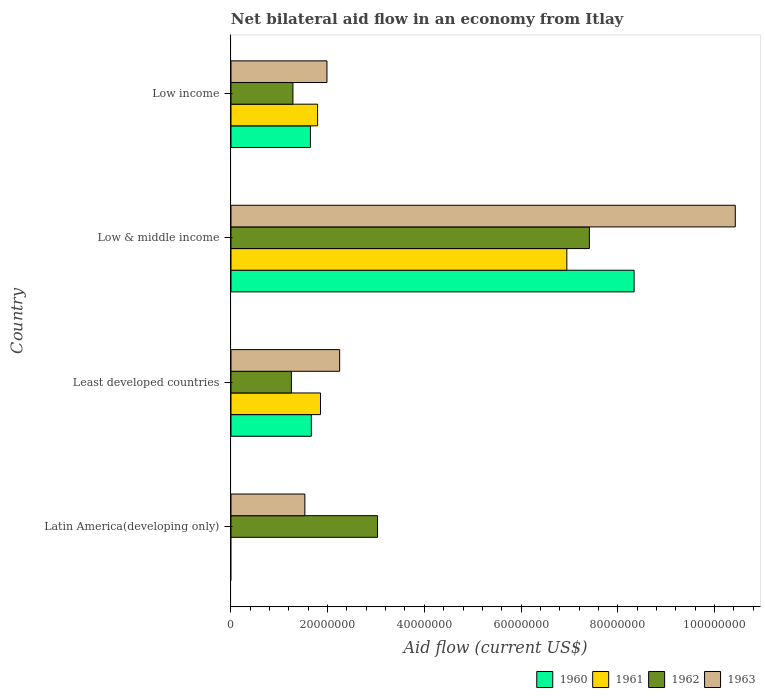How many different coloured bars are there?
Make the answer very short. 4. How many bars are there on the 4th tick from the top?
Your answer should be very brief. 2. What is the label of the 3rd group of bars from the top?
Keep it short and to the point. Least developed countries. In how many cases, is the number of bars for a given country not equal to the number of legend labels?
Offer a very short reply. 1. What is the net bilateral aid flow in 1962 in Low income?
Your answer should be compact. 1.28e+07. Across all countries, what is the maximum net bilateral aid flow in 1960?
Provide a short and direct response. 8.34e+07. Across all countries, what is the minimum net bilateral aid flow in 1963?
Your answer should be compact. 1.53e+07. What is the total net bilateral aid flow in 1963 in the graph?
Provide a succinct answer. 1.62e+08. What is the difference between the net bilateral aid flow in 1963 in Latin America(developing only) and that in Low income?
Make the answer very short. -4.58e+06. What is the difference between the net bilateral aid flow in 1963 in Least developed countries and the net bilateral aid flow in 1961 in Low & middle income?
Ensure brevity in your answer.  -4.70e+07. What is the average net bilateral aid flow in 1962 per country?
Keep it short and to the point. 3.24e+07. What is the difference between the net bilateral aid flow in 1961 and net bilateral aid flow in 1962 in Low & middle income?
Keep it short and to the point. -4.67e+06. What is the ratio of the net bilateral aid flow in 1961 in Least developed countries to that in Low income?
Offer a terse response. 1.03. What is the difference between the highest and the second highest net bilateral aid flow in 1961?
Make the answer very short. 5.10e+07. What is the difference between the highest and the lowest net bilateral aid flow in 1961?
Offer a terse response. 6.95e+07. Is it the case that in every country, the sum of the net bilateral aid flow in 1963 and net bilateral aid flow in 1960 is greater than the sum of net bilateral aid flow in 1962 and net bilateral aid flow in 1961?
Keep it short and to the point. No. Is it the case that in every country, the sum of the net bilateral aid flow in 1963 and net bilateral aid flow in 1962 is greater than the net bilateral aid flow in 1960?
Make the answer very short. Yes. Are all the bars in the graph horizontal?
Provide a short and direct response. Yes. How many countries are there in the graph?
Ensure brevity in your answer.  4. Does the graph contain any zero values?
Your answer should be very brief. Yes. Where does the legend appear in the graph?
Give a very brief answer. Bottom right. How many legend labels are there?
Your answer should be very brief. 4. What is the title of the graph?
Offer a terse response. Net bilateral aid flow in an economy from Itlay. What is the label or title of the X-axis?
Give a very brief answer. Aid flow (current US$). What is the label or title of the Y-axis?
Ensure brevity in your answer.  Country. What is the Aid flow (current US$) in 1960 in Latin America(developing only)?
Your response must be concise. 0. What is the Aid flow (current US$) in 1962 in Latin America(developing only)?
Ensure brevity in your answer.  3.03e+07. What is the Aid flow (current US$) in 1963 in Latin America(developing only)?
Ensure brevity in your answer.  1.53e+07. What is the Aid flow (current US$) in 1960 in Least developed countries?
Make the answer very short. 1.66e+07. What is the Aid flow (current US$) in 1961 in Least developed countries?
Offer a terse response. 1.85e+07. What is the Aid flow (current US$) in 1962 in Least developed countries?
Offer a very short reply. 1.25e+07. What is the Aid flow (current US$) of 1963 in Least developed countries?
Make the answer very short. 2.25e+07. What is the Aid flow (current US$) in 1960 in Low & middle income?
Offer a very short reply. 8.34e+07. What is the Aid flow (current US$) in 1961 in Low & middle income?
Provide a short and direct response. 6.95e+07. What is the Aid flow (current US$) of 1962 in Low & middle income?
Keep it short and to the point. 7.42e+07. What is the Aid flow (current US$) of 1963 in Low & middle income?
Give a very brief answer. 1.04e+08. What is the Aid flow (current US$) in 1960 in Low income?
Your response must be concise. 1.64e+07. What is the Aid flow (current US$) in 1961 in Low income?
Ensure brevity in your answer.  1.79e+07. What is the Aid flow (current US$) of 1962 in Low income?
Offer a very short reply. 1.28e+07. What is the Aid flow (current US$) of 1963 in Low income?
Offer a very short reply. 1.99e+07. Across all countries, what is the maximum Aid flow (current US$) of 1960?
Give a very brief answer. 8.34e+07. Across all countries, what is the maximum Aid flow (current US$) in 1961?
Your response must be concise. 6.95e+07. Across all countries, what is the maximum Aid flow (current US$) in 1962?
Make the answer very short. 7.42e+07. Across all countries, what is the maximum Aid flow (current US$) of 1963?
Keep it short and to the point. 1.04e+08. Across all countries, what is the minimum Aid flow (current US$) in 1960?
Offer a very short reply. 0. Across all countries, what is the minimum Aid flow (current US$) in 1962?
Your answer should be very brief. 1.25e+07. Across all countries, what is the minimum Aid flow (current US$) of 1963?
Keep it short and to the point. 1.53e+07. What is the total Aid flow (current US$) of 1960 in the graph?
Offer a very short reply. 1.16e+08. What is the total Aid flow (current US$) in 1961 in the graph?
Make the answer very short. 1.06e+08. What is the total Aid flow (current US$) in 1962 in the graph?
Make the answer very short. 1.30e+08. What is the total Aid flow (current US$) in 1963 in the graph?
Provide a short and direct response. 1.62e+08. What is the difference between the Aid flow (current US$) in 1962 in Latin America(developing only) and that in Least developed countries?
Your answer should be compact. 1.78e+07. What is the difference between the Aid flow (current US$) in 1963 in Latin America(developing only) and that in Least developed countries?
Offer a terse response. -7.20e+06. What is the difference between the Aid flow (current US$) in 1962 in Latin America(developing only) and that in Low & middle income?
Provide a succinct answer. -4.38e+07. What is the difference between the Aid flow (current US$) in 1963 in Latin America(developing only) and that in Low & middle income?
Provide a short and direct response. -8.90e+07. What is the difference between the Aid flow (current US$) in 1962 in Latin America(developing only) and that in Low income?
Offer a very short reply. 1.75e+07. What is the difference between the Aid flow (current US$) in 1963 in Latin America(developing only) and that in Low income?
Ensure brevity in your answer.  -4.58e+06. What is the difference between the Aid flow (current US$) of 1960 in Least developed countries and that in Low & middle income?
Give a very brief answer. -6.68e+07. What is the difference between the Aid flow (current US$) of 1961 in Least developed countries and that in Low & middle income?
Offer a very short reply. -5.10e+07. What is the difference between the Aid flow (current US$) of 1962 in Least developed countries and that in Low & middle income?
Your response must be concise. -6.16e+07. What is the difference between the Aid flow (current US$) of 1963 in Least developed countries and that in Low & middle income?
Your answer should be compact. -8.18e+07. What is the difference between the Aid flow (current US$) in 1960 in Least developed countries and that in Low income?
Your answer should be very brief. 1.90e+05. What is the difference between the Aid flow (current US$) of 1962 in Least developed countries and that in Low income?
Make the answer very short. -3.20e+05. What is the difference between the Aid flow (current US$) in 1963 in Least developed countries and that in Low income?
Make the answer very short. 2.62e+06. What is the difference between the Aid flow (current US$) in 1960 in Low & middle income and that in Low income?
Provide a succinct answer. 6.70e+07. What is the difference between the Aid flow (current US$) of 1961 in Low & middle income and that in Low income?
Make the answer very short. 5.16e+07. What is the difference between the Aid flow (current US$) in 1962 in Low & middle income and that in Low income?
Your response must be concise. 6.13e+07. What is the difference between the Aid flow (current US$) in 1963 in Low & middle income and that in Low income?
Offer a very short reply. 8.45e+07. What is the difference between the Aid flow (current US$) of 1962 in Latin America(developing only) and the Aid flow (current US$) of 1963 in Least developed countries?
Offer a very short reply. 7.84e+06. What is the difference between the Aid flow (current US$) of 1962 in Latin America(developing only) and the Aid flow (current US$) of 1963 in Low & middle income?
Your answer should be very brief. -7.40e+07. What is the difference between the Aid flow (current US$) of 1962 in Latin America(developing only) and the Aid flow (current US$) of 1963 in Low income?
Give a very brief answer. 1.05e+07. What is the difference between the Aid flow (current US$) of 1960 in Least developed countries and the Aid flow (current US$) of 1961 in Low & middle income?
Your response must be concise. -5.28e+07. What is the difference between the Aid flow (current US$) of 1960 in Least developed countries and the Aid flow (current US$) of 1962 in Low & middle income?
Your answer should be compact. -5.75e+07. What is the difference between the Aid flow (current US$) in 1960 in Least developed countries and the Aid flow (current US$) in 1963 in Low & middle income?
Make the answer very short. -8.77e+07. What is the difference between the Aid flow (current US$) in 1961 in Least developed countries and the Aid flow (current US$) in 1962 in Low & middle income?
Your answer should be very brief. -5.56e+07. What is the difference between the Aid flow (current US$) in 1961 in Least developed countries and the Aid flow (current US$) in 1963 in Low & middle income?
Offer a very short reply. -8.58e+07. What is the difference between the Aid flow (current US$) of 1962 in Least developed countries and the Aid flow (current US$) of 1963 in Low & middle income?
Your response must be concise. -9.18e+07. What is the difference between the Aid flow (current US$) of 1960 in Least developed countries and the Aid flow (current US$) of 1961 in Low income?
Offer a very short reply. -1.29e+06. What is the difference between the Aid flow (current US$) in 1960 in Least developed countries and the Aid flow (current US$) in 1962 in Low income?
Offer a terse response. 3.81e+06. What is the difference between the Aid flow (current US$) in 1960 in Least developed countries and the Aid flow (current US$) in 1963 in Low income?
Give a very brief answer. -3.23e+06. What is the difference between the Aid flow (current US$) in 1961 in Least developed countries and the Aid flow (current US$) in 1962 in Low income?
Keep it short and to the point. 5.70e+06. What is the difference between the Aid flow (current US$) of 1961 in Least developed countries and the Aid flow (current US$) of 1963 in Low income?
Make the answer very short. -1.34e+06. What is the difference between the Aid flow (current US$) of 1962 in Least developed countries and the Aid flow (current US$) of 1963 in Low income?
Make the answer very short. -7.36e+06. What is the difference between the Aid flow (current US$) in 1960 in Low & middle income and the Aid flow (current US$) in 1961 in Low income?
Your response must be concise. 6.55e+07. What is the difference between the Aid flow (current US$) in 1960 in Low & middle income and the Aid flow (current US$) in 1962 in Low income?
Keep it short and to the point. 7.06e+07. What is the difference between the Aid flow (current US$) in 1960 in Low & middle income and the Aid flow (current US$) in 1963 in Low income?
Make the answer very short. 6.35e+07. What is the difference between the Aid flow (current US$) of 1961 in Low & middle income and the Aid flow (current US$) of 1962 in Low income?
Provide a short and direct response. 5.67e+07. What is the difference between the Aid flow (current US$) in 1961 in Low & middle income and the Aid flow (current US$) in 1963 in Low income?
Provide a short and direct response. 4.96e+07. What is the difference between the Aid flow (current US$) of 1962 in Low & middle income and the Aid flow (current US$) of 1963 in Low income?
Provide a succinct answer. 5.43e+07. What is the average Aid flow (current US$) of 1960 per country?
Offer a very short reply. 2.91e+07. What is the average Aid flow (current US$) in 1961 per country?
Provide a succinct answer. 2.65e+07. What is the average Aid flow (current US$) in 1962 per country?
Make the answer very short. 3.24e+07. What is the average Aid flow (current US$) in 1963 per country?
Your response must be concise. 4.05e+07. What is the difference between the Aid flow (current US$) in 1962 and Aid flow (current US$) in 1963 in Latin America(developing only)?
Your answer should be compact. 1.50e+07. What is the difference between the Aid flow (current US$) in 1960 and Aid flow (current US$) in 1961 in Least developed countries?
Your answer should be very brief. -1.89e+06. What is the difference between the Aid flow (current US$) in 1960 and Aid flow (current US$) in 1962 in Least developed countries?
Give a very brief answer. 4.13e+06. What is the difference between the Aid flow (current US$) in 1960 and Aid flow (current US$) in 1963 in Least developed countries?
Make the answer very short. -5.85e+06. What is the difference between the Aid flow (current US$) in 1961 and Aid flow (current US$) in 1962 in Least developed countries?
Your response must be concise. 6.02e+06. What is the difference between the Aid flow (current US$) in 1961 and Aid flow (current US$) in 1963 in Least developed countries?
Your answer should be very brief. -3.96e+06. What is the difference between the Aid flow (current US$) in 1962 and Aid flow (current US$) in 1963 in Least developed countries?
Your answer should be compact. -9.98e+06. What is the difference between the Aid flow (current US$) in 1960 and Aid flow (current US$) in 1961 in Low & middle income?
Your response must be concise. 1.39e+07. What is the difference between the Aid flow (current US$) of 1960 and Aid flow (current US$) of 1962 in Low & middle income?
Offer a terse response. 9.25e+06. What is the difference between the Aid flow (current US$) in 1960 and Aid flow (current US$) in 1963 in Low & middle income?
Give a very brief answer. -2.09e+07. What is the difference between the Aid flow (current US$) in 1961 and Aid flow (current US$) in 1962 in Low & middle income?
Your response must be concise. -4.67e+06. What is the difference between the Aid flow (current US$) of 1961 and Aid flow (current US$) of 1963 in Low & middle income?
Offer a terse response. -3.48e+07. What is the difference between the Aid flow (current US$) of 1962 and Aid flow (current US$) of 1963 in Low & middle income?
Offer a terse response. -3.02e+07. What is the difference between the Aid flow (current US$) in 1960 and Aid flow (current US$) in 1961 in Low income?
Offer a terse response. -1.48e+06. What is the difference between the Aid flow (current US$) in 1960 and Aid flow (current US$) in 1962 in Low income?
Your response must be concise. 3.62e+06. What is the difference between the Aid flow (current US$) of 1960 and Aid flow (current US$) of 1963 in Low income?
Your answer should be compact. -3.42e+06. What is the difference between the Aid flow (current US$) of 1961 and Aid flow (current US$) of 1962 in Low income?
Your response must be concise. 5.10e+06. What is the difference between the Aid flow (current US$) of 1961 and Aid flow (current US$) of 1963 in Low income?
Give a very brief answer. -1.94e+06. What is the difference between the Aid flow (current US$) in 1962 and Aid flow (current US$) in 1963 in Low income?
Give a very brief answer. -7.04e+06. What is the ratio of the Aid flow (current US$) of 1962 in Latin America(developing only) to that in Least developed countries?
Give a very brief answer. 2.43. What is the ratio of the Aid flow (current US$) of 1963 in Latin America(developing only) to that in Least developed countries?
Your answer should be very brief. 0.68. What is the ratio of the Aid flow (current US$) of 1962 in Latin America(developing only) to that in Low & middle income?
Keep it short and to the point. 0.41. What is the ratio of the Aid flow (current US$) of 1963 in Latin America(developing only) to that in Low & middle income?
Offer a very short reply. 0.15. What is the ratio of the Aid flow (current US$) of 1962 in Latin America(developing only) to that in Low income?
Offer a terse response. 2.37. What is the ratio of the Aid flow (current US$) of 1963 in Latin America(developing only) to that in Low income?
Ensure brevity in your answer.  0.77. What is the ratio of the Aid flow (current US$) of 1960 in Least developed countries to that in Low & middle income?
Your response must be concise. 0.2. What is the ratio of the Aid flow (current US$) in 1961 in Least developed countries to that in Low & middle income?
Give a very brief answer. 0.27. What is the ratio of the Aid flow (current US$) in 1962 in Least developed countries to that in Low & middle income?
Provide a short and direct response. 0.17. What is the ratio of the Aid flow (current US$) in 1963 in Least developed countries to that in Low & middle income?
Make the answer very short. 0.22. What is the ratio of the Aid flow (current US$) of 1960 in Least developed countries to that in Low income?
Offer a terse response. 1.01. What is the ratio of the Aid flow (current US$) of 1961 in Least developed countries to that in Low income?
Offer a terse response. 1.03. What is the ratio of the Aid flow (current US$) of 1963 in Least developed countries to that in Low income?
Your answer should be very brief. 1.13. What is the ratio of the Aid flow (current US$) of 1960 in Low & middle income to that in Low income?
Keep it short and to the point. 5.07. What is the ratio of the Aid flow (current US$) in 1961 in Low & middle income to that in Low income?
Offer a very short reply. 3.88. What is the ratio of the Aid flow (current US$) of 1962 in Low & middle income to that in Low income?
Keep it short and to the point. 5.78. What is the ratio of the Aid flow (current US$) in 1963 in Low & middle income to that in Low income?
Your answer should be very brief. 5.25. What is the difference between the highest and the second highest Aid flow (current US$) of 1960?
Offer a terse response. 6.68e+07. What is the difference between the highest and the second highest Aid flow (current US$) in 1961?
Offer a very short reply. 5.10e+07. What is the difference between the highest and the second highest Aid flow (current US$) in 1962?
Your answer should be very brief. 4.38e+07. What is the difference between the highest and the second highest Aid flow (current US$) in 1963?
Provide a succinct answer. 8.18e+07. What is the difference between the highest and the lowest Aid flow (current US$) of 1960?
Your answer should be very brief. 8.34e+07. What is the difference between the highest and the lowest Aid flow (current US$) in 1961?
Your answer should be compact. 6.95e+07. What is the difference between the highest and the lowest Aid flow (current US$) in 1962?
Offer a very short reply. 6.16e+07. What is the difference between the highest and the lowest Aid flow (current US$) of 1963?
Make the answer very short. 8.90e+07. 